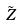<formula> <loc_0><loc_0><loc_500><loc_500>\tilde { Z }</formula> 